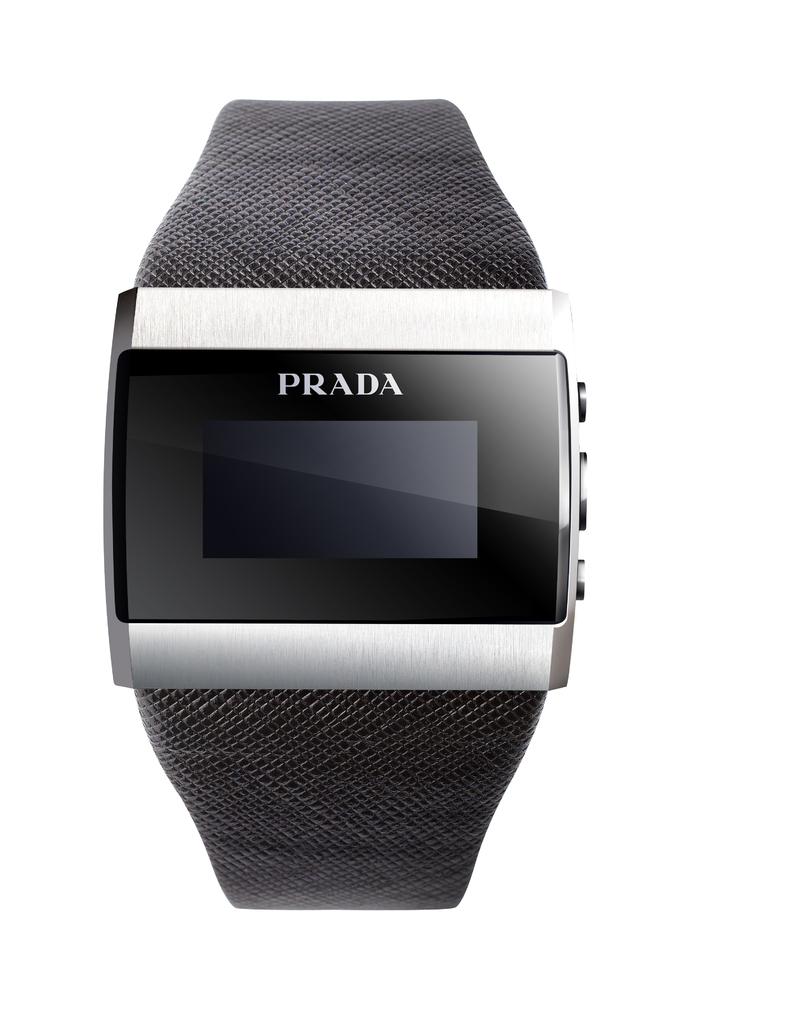What brand is this watch?
Keep it short and to the point. Prada. 